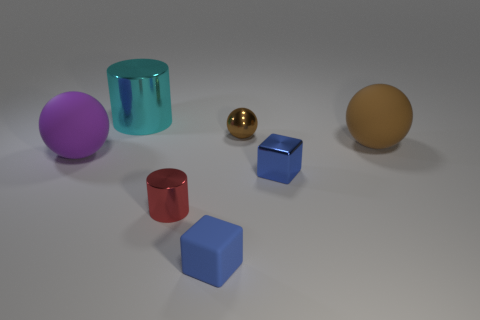How many things are small purple balls or large brown balls?
Offer a very short reply. 1. What is the shape of the small metallic object that is the same color as the tiny rubber cube?
Offer a very short reply. Cube. How big is the metal object that is both to the left of the blue shiny object and in front of the brown shiny ball?
Offer a terse response. Small. How many green matte things are there?
Your answer should be compact. 0. What number of spheres are either brown metallic things or tiny red metallic things?
Keep it short and to the point. 1. What number of tiny cylinders are in front of the block that is left of the small blue object behind the tiny blue rubber object?
Give a very brief answer. 0. There is a metal cube that is the same size as the red shiny object; what color is it?
Offer a very short reply. Blue. How many other things are there of the same color as the small metallic cylinder?
Your answer should be very brief. 0. Are there more small red cylinders that are left of the large cyan metallic thing than large rubber things?
Provide a short and direct response. No. Do the big purple thing and the red thing have the same material?
Offer a very short reply. No. 